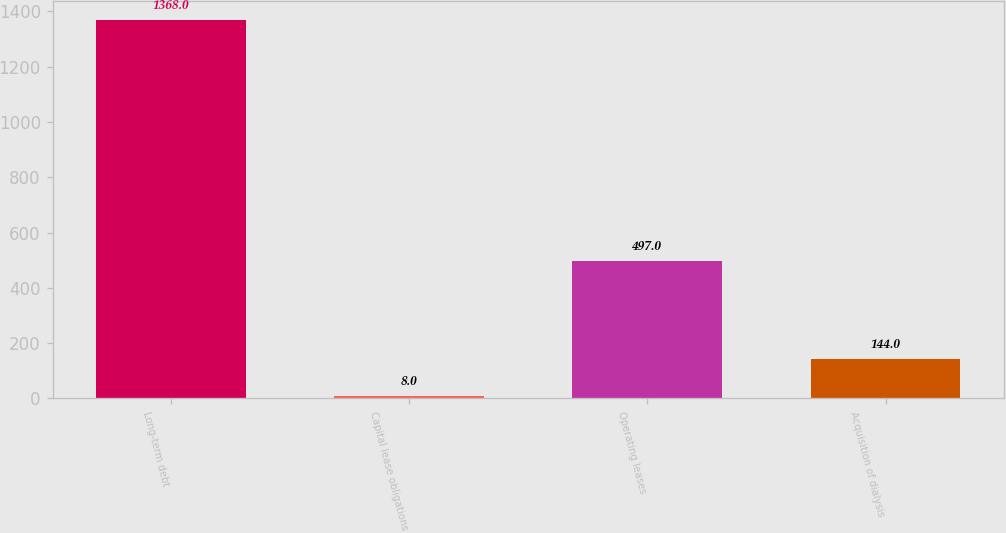Convert chart. <chart><loc_0><loc_0><loc_500><loc_500><bar_chart><fcel>Long-term debt<fcel>Capital lease obligations<fcel>Operating leases<fcel>Acquisition of dialysis<nl><fcel>1368<fcel>8<fcel>497<fcel>144<nl></chart> 